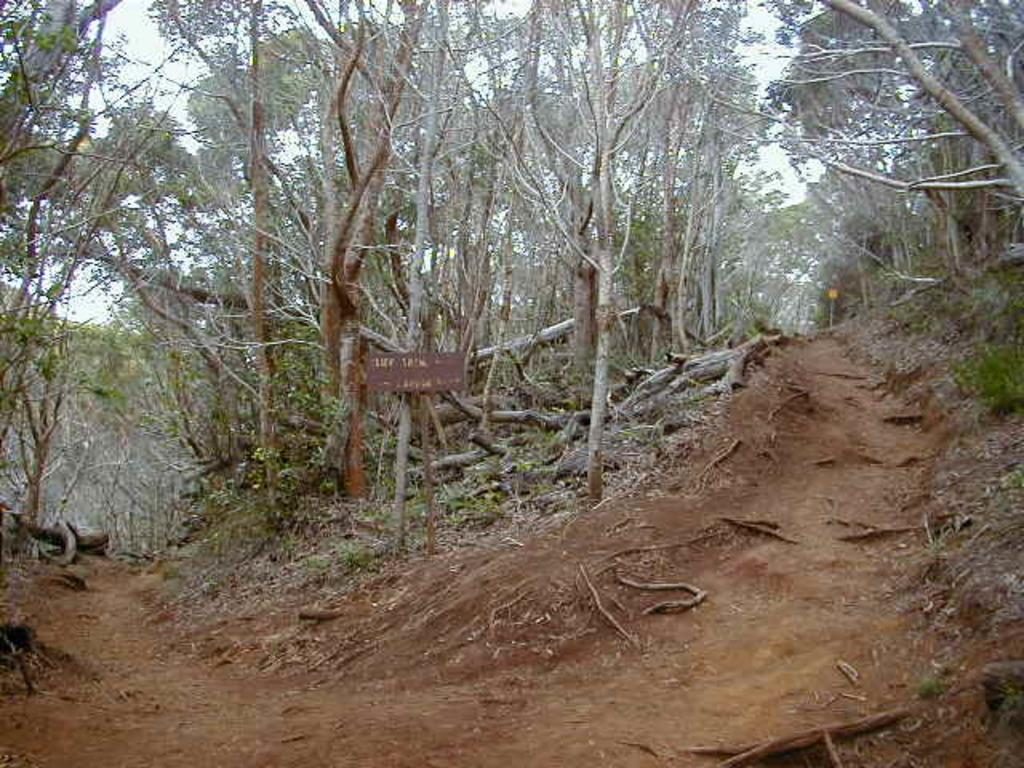What is the main subject of the image? The main subject of the image is a way. What type of natural elements can be seen in the image? There are trees visible in the image. What man-made object is present in the image? There is a sign board in the image. What is visible at the top of the image? The sky is visible at the top of the image. What type of suit is the person wearing in the image? There is no person present in the image, so it is not possible to determine what type of suit they might be wearing. 